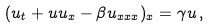Convert formula to latex. <formula><loc_0><loc_0><loc_500><loc_500>( u _ { t } + u u _ { x } - \beta u _ { x x x } ) _ { x } = \gamma u \, ,</formula> 